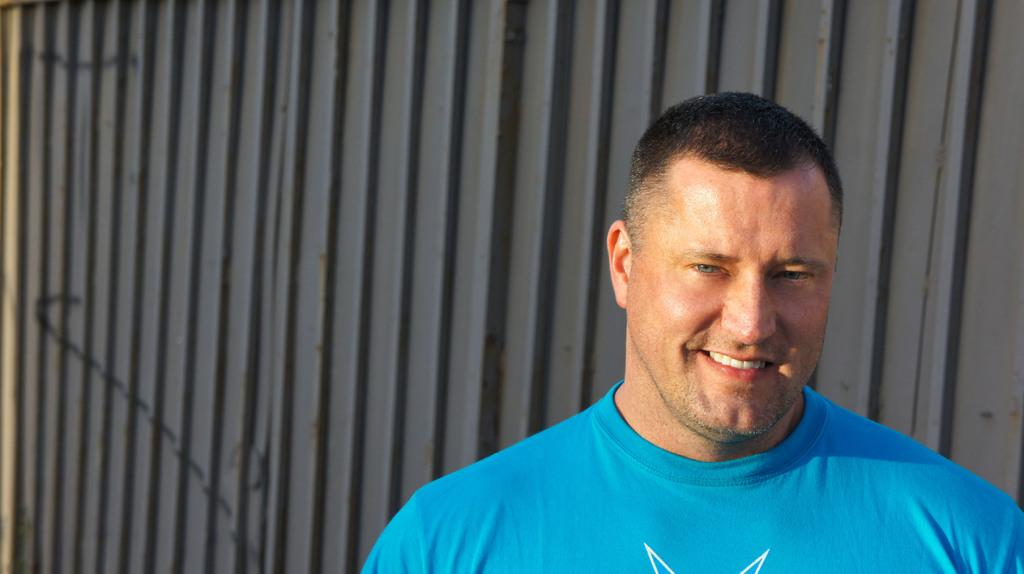What is located on the right side of the image? There is a person on the right side of the image. What is the person wearing? The person is wearing a blue t-shirt. What is the person's facial expression? The person is smiling. What can be seen in the background of the image? There is a wall in the background of the image. What is the color of the background? The background color is gray. What month is depicted on the map in the image? There is no map present in the image, so it is not possible to determine the month depicted. 